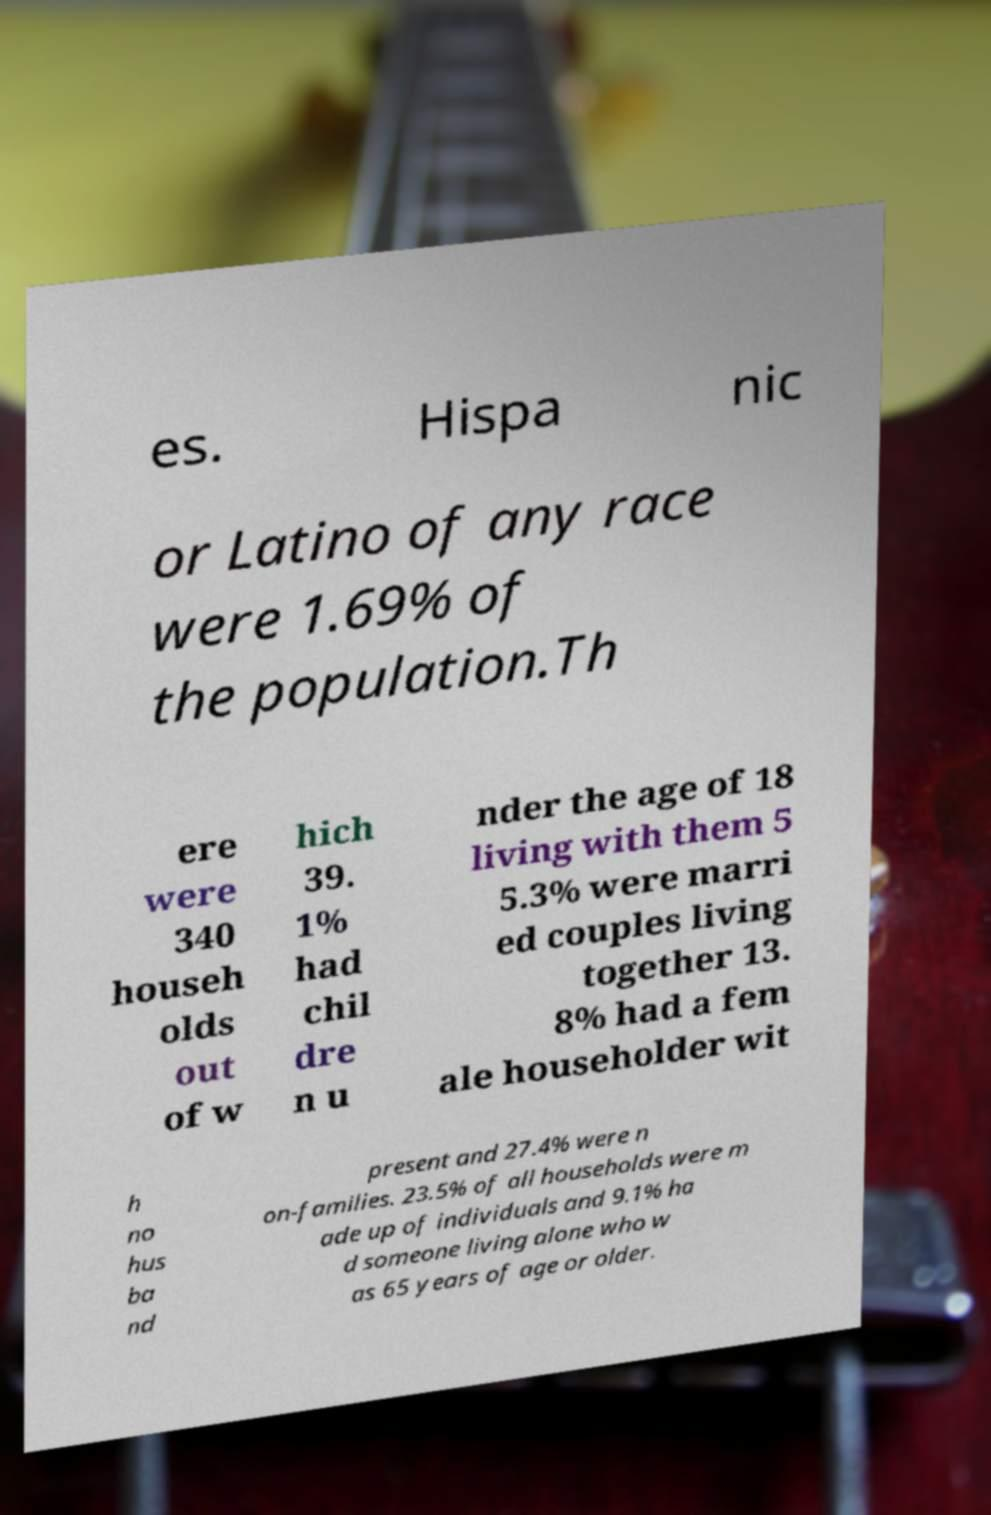Could you extract and type out the text from this image? es. Hispa nic or Latino of any race were 1.69% of the population.Th ere were 340 househ olds out of w hich 39. 1% had chil dre n u nder the age of 18 living with them 5 5.3% were marri ed couples living together 13. 8% had a fem ale householder wit h no hus ba nd present and 27.4% were n on-families. 23.5% of all households were m ade up of individuals and 9.1% ha d someone living alone who w as 65 years of age or older. 